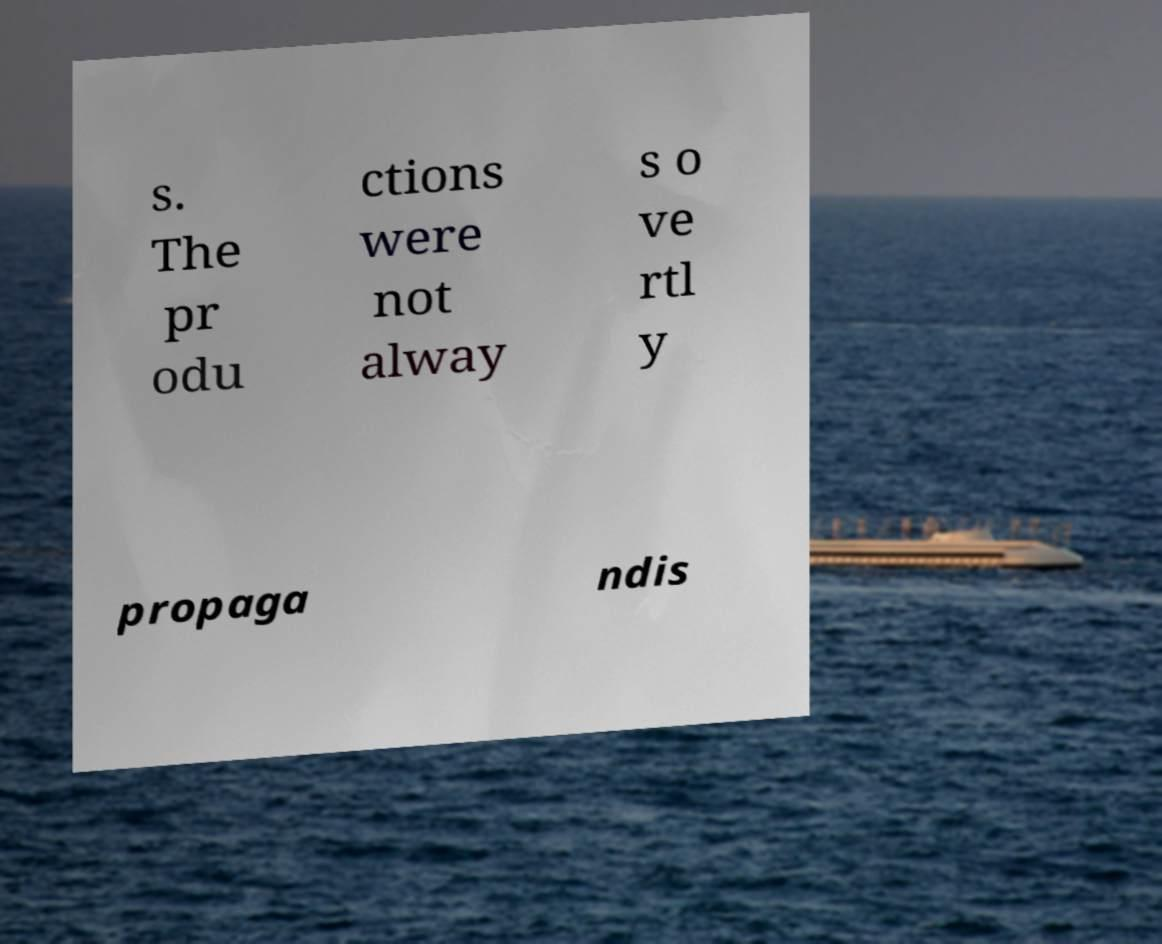There's text embedded in this image that I need extracted. Can you transcribe it verbatim? s. The pr odu ctions were not alway s o ve rtl y propaga ndis 